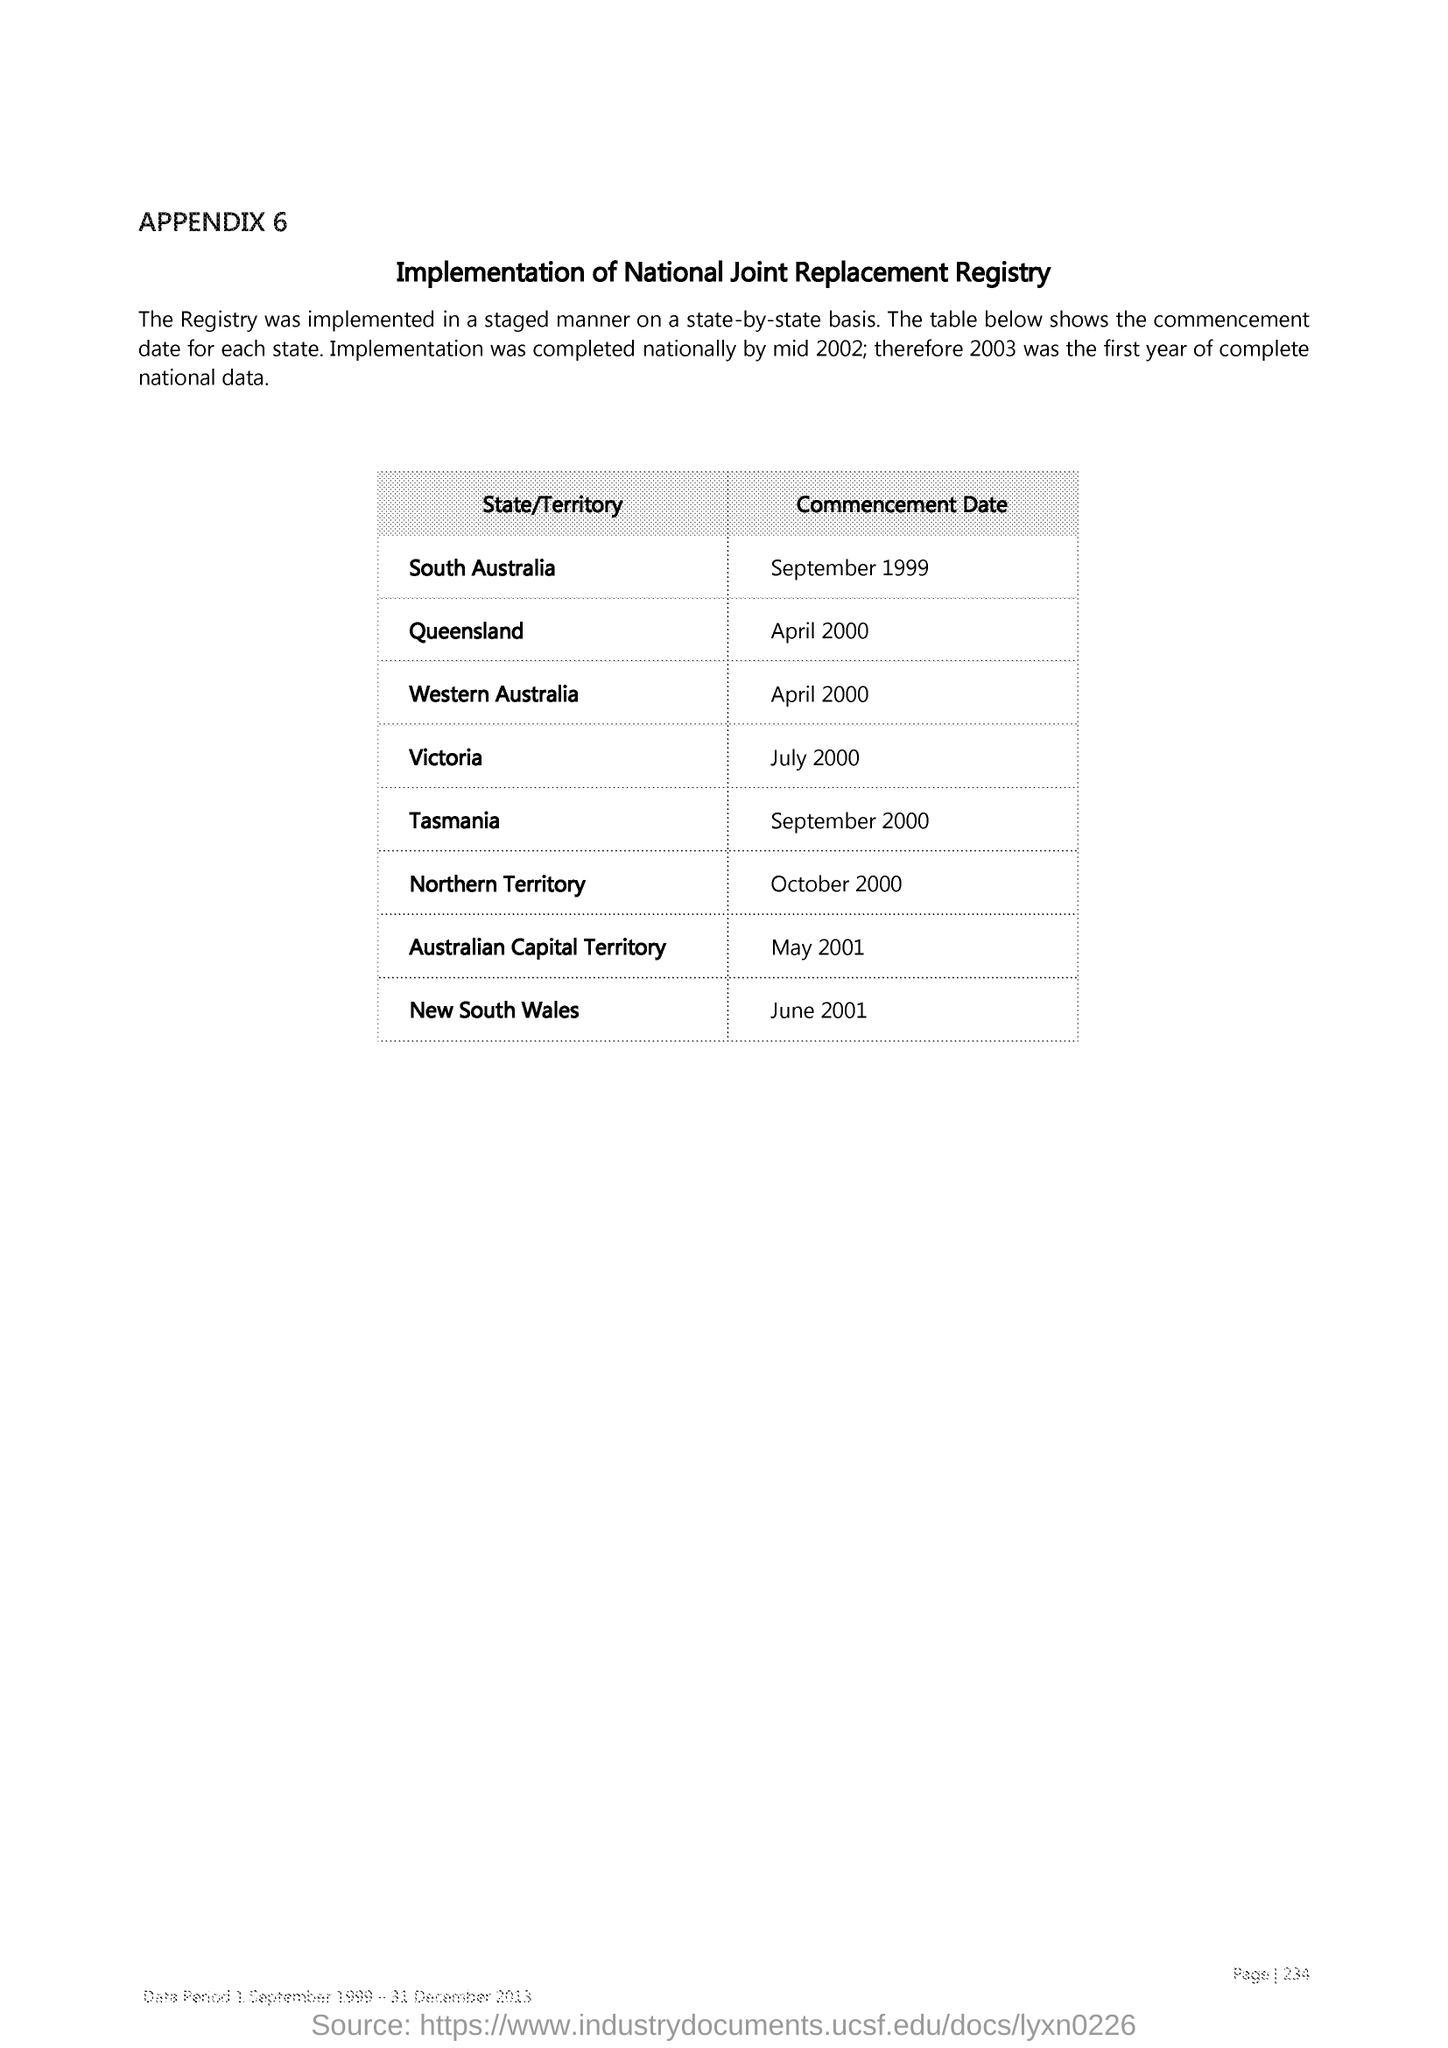Indicate a few pertinent items in this graphic. The commencement date of Queensland is April 2000. The commencement date of Victoria was in July 2000. The commencement date of New South Wales was June 2001. 